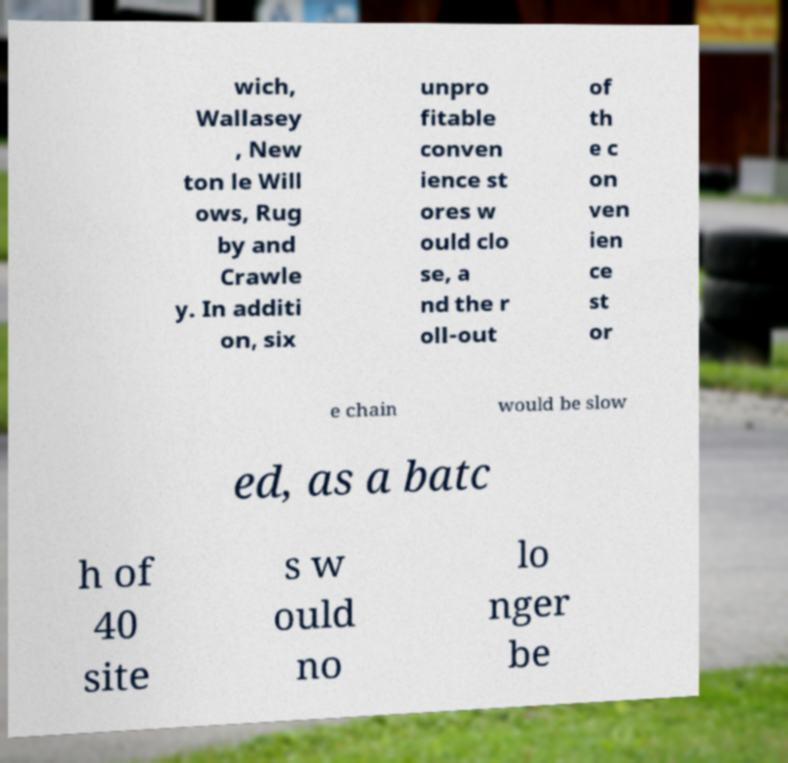Can you read and provide the text displayed in the image?This photo seems to have some interesting text. Can you extract and type it out for me? wich, Wallasey , New ton le Will ows, Rug by and Crawle y. In additi on, six unpro fitable conven ience st ores w ould clo se, a nd the r oll-out of th e c on ven ien ce st or e chain would be slow ed, as a batc h of 40 site s w ould no lo nger be 